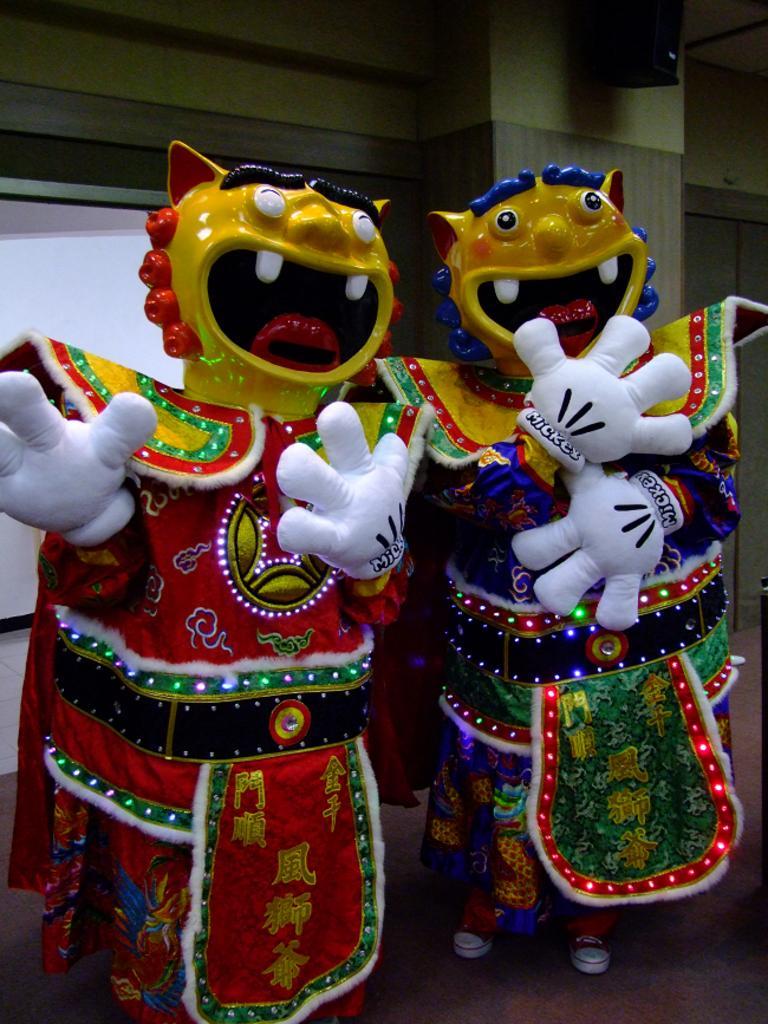Please provide a concise description of this image. In this image in the foreground there are miniature, and in the background there are boards and wall and some object it looks like a speaker. 